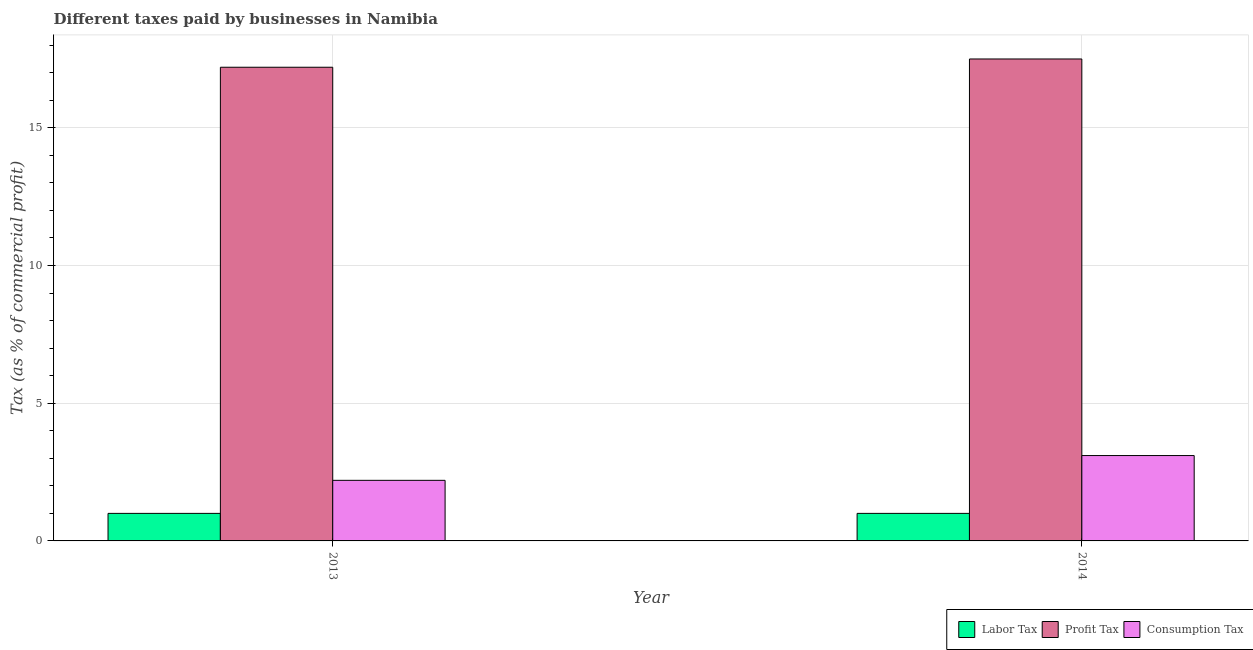How many groups of bars are there?
Make the answer very short. 2. Are the number of bars on each tick of the X-axis equal?
Ensure brevity in your answer.  Yes. In how many cases, is the number of bars for a given year not equal to the number of legend labels?
Provide a short and direct response. 0. What is the percentage of profit tax in 2014?
Provide a short and direct response. 17.5. In which year was the percentage of profit tax minimum?
Keep it short and to the point. 2013. What is the total percentage of consumption tax in the graph?
Provide a short and direct response. 5.3. What is the difference between the percentage of profit tax in 2014 and the percentage of consumption tax in 2013?
Your response must be concise. 0.3. In how many years, is the percentage of labor tax greater than 9 %?
Give a very brief answer. 0. Is the percentage of consumption tax in 2013 less than that in 2014?
Your response must be concise. Yes. In how many years, is the percentage of profit tax greater than the average percentage of profit tax taken over all years?
Give a very brief answer. 1. What does the 3rd bar from the left in 2014 represents?
Provide a short and direct response. Consumption Tax. What does the 3rd bar from the right in 2014 represents?
Keep it short and to the point. Labor Tax. How many bars are there?
Your answer should be compact. 6. How many years are there in the graph?
Provide a succinct answer. 2. Does the graph contain any zero values?
Ensure brevity in your answer.  No. Where does the legend appear in the graph?
Ensure brevity in your answer.  Bottom right. How many legend labels are there?
Provide a succinct answer. 3. How are the legend labels stacked?
Provide a succinct answer. Horizontal. What is the title of the graph?
Give a very brief answer. Different taxes paid by businesses in Namibia. Does "Capital account" appear as one of the legend labels in the graph?
Provide a succinct answer. No. What is the label or title of the X-axis?
Make the answer very short. Year. What is the label or title of the Y-axis?
Offer a very short reply. Tax (as % of commercial profit). What is the Tax (as % of commercial profit) in Labor Tax in 2013?
Provide a short and direct response. 1. What is the Tax (as % of commercial profit) of Labor Tax in 2014?
Provide a succinct answer. 1. What is the Tax (as % of commercial profit) in Profit Tax in 2014?
Keep it short and to the point. 17.5. Across all years, what is the minimum Tax (as % of commercial profit) of Profit Tax?
Make the answer very short. 17.2. Across all years, what is the minimum Tax (as % of commercial profit) in Consumption Tax?
Offer a very short reply. 2.2. What is the total Tax (as % of commercial profit) in Profit Tax in the graph?
Offer a very short reply. 34.7. What is the difference between the Tax (as % of commercial profit) in Labor Tax in 2013 and the Tax (as % of commercial profit) in Profit Tax in 2014?
Your answer should be very brief. -16.5. What is the difference between the Tax (as % of commercial profit) of Labor Tax in 2013 and the Tax (as % of commercial profit) of Consumption Tax in 2014?
Make the answer very short. -2.1. What is the difference between the Tax (as % of commercial profit) in Profit Tax in 2013 and the Tax (as % of commercial profit) in Consumption Tax in 2014?
Provide a short and direct response. 14.1. What is the average Tax (as % of commercial profit) of Labor Tax per year?
Offer a terse response. 1. What is the average Tax (as % of commercial profit) in Profit Tax per year?
Your answer should be very brief. 17.35. What is the average Tax (as % of commercial profit) in Consumption Tax per year?
Provide a succinct answer. 2.65. In the year 2013, what is the difference between the Tax (as % of commercial profit) in Labor Tax and Tax (as % of commercial profit) in Profit Tax?
Provide a succinct answer. -16.2. In the year 2014, what is the difference between the Tax (as % of commercial profit) of Labor Tax and Tax (as % of commercial profit) of Profit Tax?
Give a very brief answer. -16.5. In the year 2014, what is the difference between the Tax (as % of commercial profit) in Labor Tax and Tax (as % of commercial profit) in Consumption Tax?
Offer a terse response. -2.1. In the year 2014, what is the difference between the Tax (as % of commercial profit) in Profit Tax and Tax (as % of commercial profit) in Consumption Tax?
Offer a very short reply. 14.4. What is the ratio of the Tax (as % of commercial profit) in Profit Tax in 2013 to that in 2014?
Ensure brevity in your answer.  0.98. What is the ratio of the Tax (as % of commercial profit) of Consumption Tax in 2013 to that in 2014?
Your answer should be very brief. 0.71. What is the difference between the highest and the second highest Tax (as % of commercial profit) of Consumption Tax?
Your answer should be compact. 0.9. What is the difference between the highest and the lowest Tax (as % of commercial profit) in Labor Tax?
Ensure brevity in your answer.  0. 